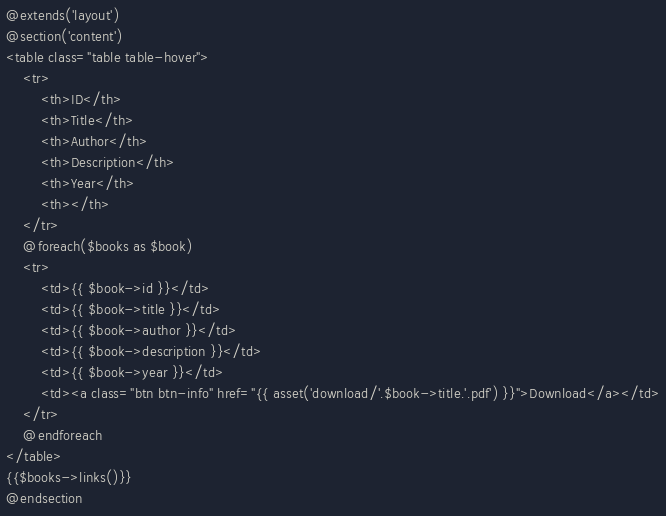Convert code to text. <code><loc_0><loc_0><loc_500><loc_500><_PHP_>@extends('layout')
@section('content')
<table class="table table-hover">
    <tr>
        <th>ID</th>
        <th>Title</th>
        <th>Author</th>
        <th>Description</th>
        <th>Year</th>
        <th></th>
    </tr>
    @foreach($books as $book)
    <tr>
        <td>{{ $book->id }}</td>
        <td>{{ $book->title }}</td>
        <td>{{ $book->author }}</td>
        <td>{{ $book->description }}</td>
        <td>{{ $book->year }}</td>
        <td><a class="btn btn-info" href="{{ asset('download/'.$book->title.'.pdf') }}">Download</a></td>
    </tr>
    @endforeach
</table>
{{$books->links()}}
@endsection</code> 